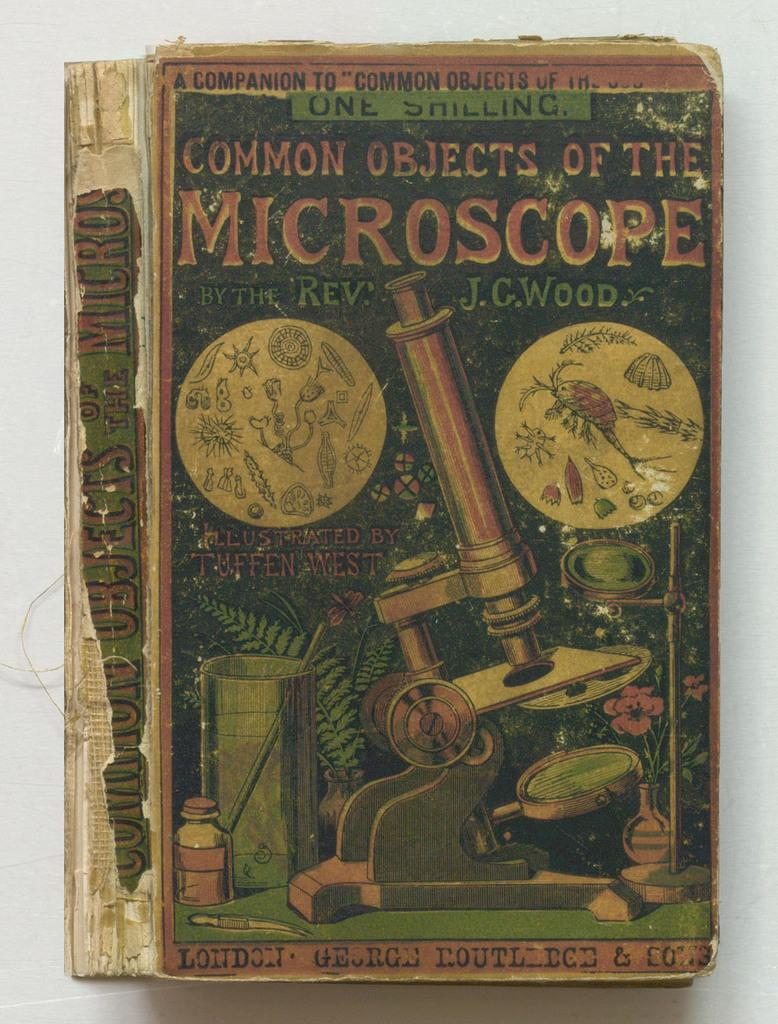<image>
Write a terse but informative summary of the picture. Vintage book that is titled Common objects of the microscope by the Rev. JC Wood. 